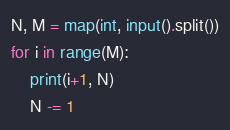Convert code to text. <code><loc_0><loc_0><loc_500><loc_500><_Python_>N, M = map(int, input().split())
for i in range(M):
    print(i+1, N)
    N -= 1
</code> 